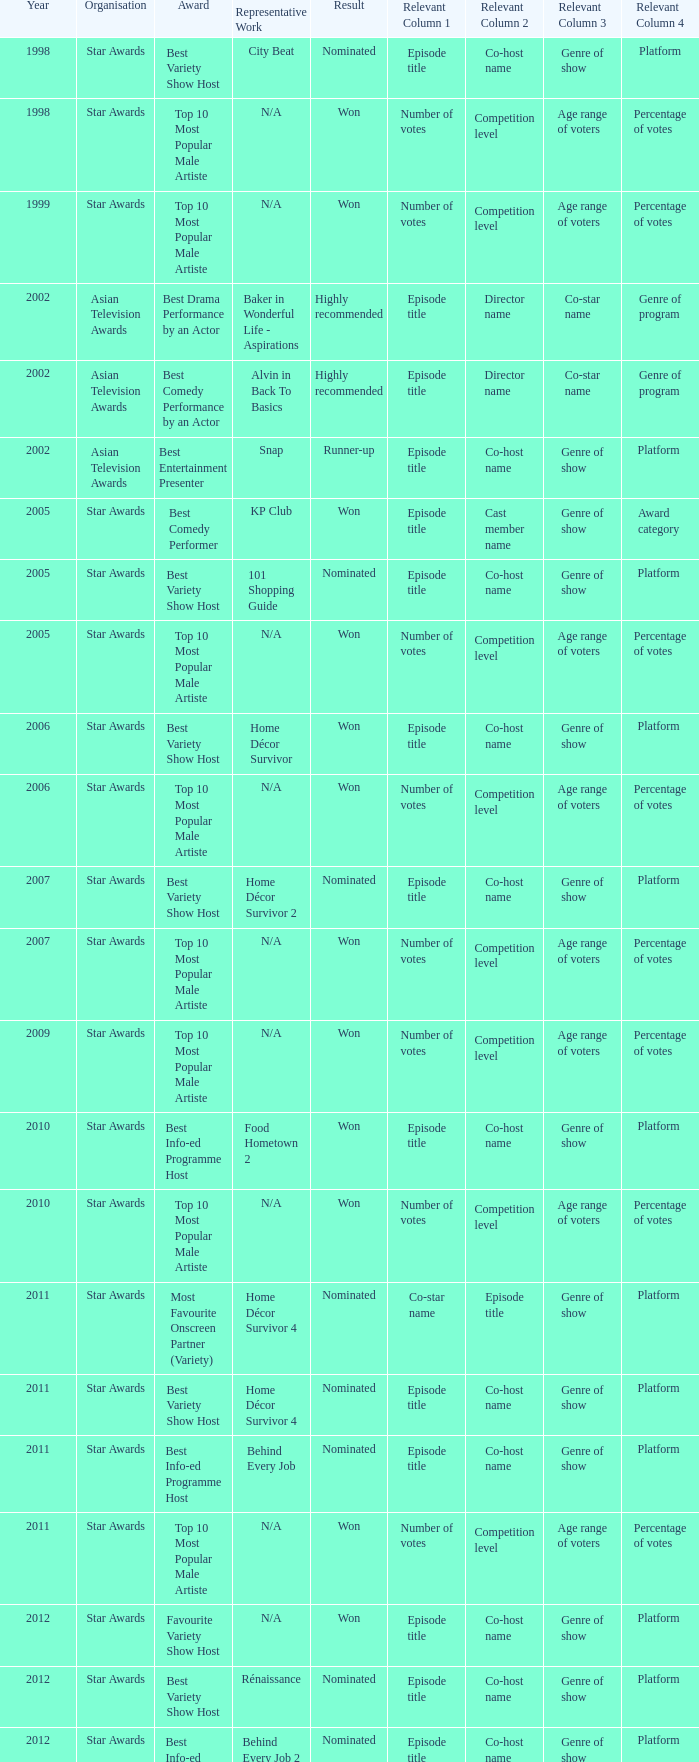What is the award for 1998 with Representative Work of city beat? Best Variety Show Host. 